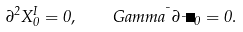<formula> <loc_0><loc_0><loc_500><loc_500>\partial ^ { 2 } X _ { 0 } ^ { I } = 0 , \quad G a m m a ^ { \mu } \partial _ { \mu } \Psi _ { 0 } = 0 .</formula> 